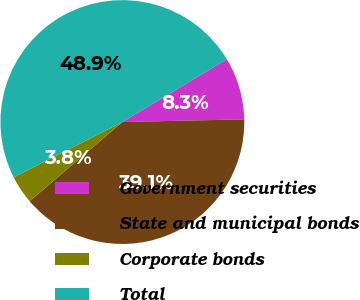<chart> <loc_0><loc_0><loc_500><loc_500><pie_chart><fcel>Government securities<fcel>State and municipal bonds<fcel>Corporate bonds<fcel>Total<nl><fcel>8.27%<fcel>39.1%<fcel>3.76%<fcel>48.87%<nl></chart> 